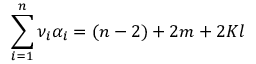Convert formula to latex. <formula><loc_0><loc_0><loc_500><loc_500>\sum _ { i = 1 } ^ { n } \nu _ { i } \alpha _ { i } = ( n - 2 ) + 2 m + 2 K l</formula> 